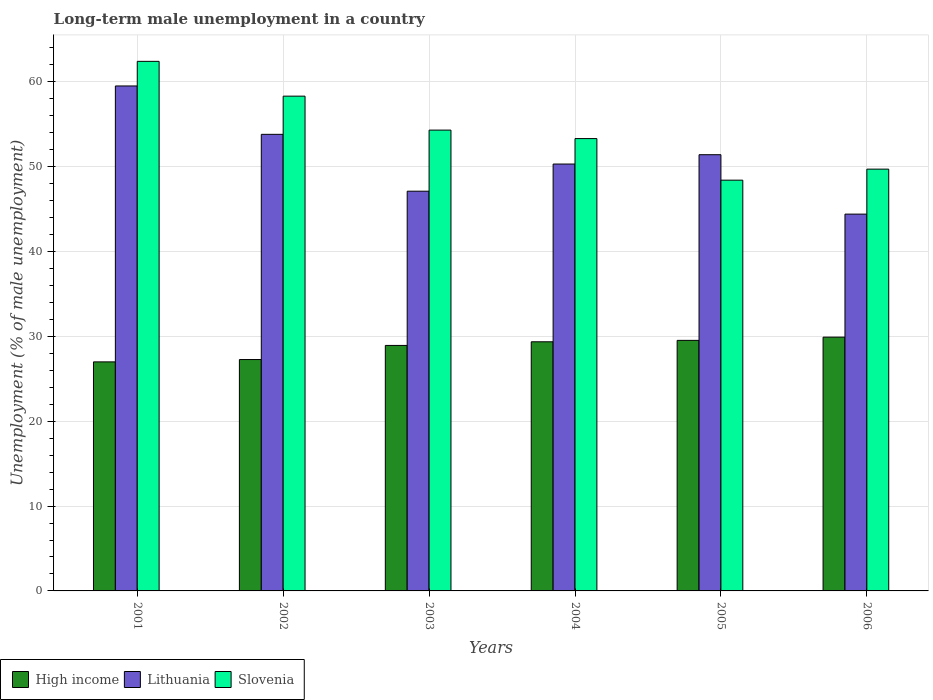How many different coloured bars are there?
Provide a succinct answer. 3. Are the number of bars on each tick of the X-axis equal?
Your answer should be very brief. Yes. How many bars are there on the 2nd tick from the left?
Your answer should be very brief. 3. How many bars are there on the 5th tick from the right?
Provide a succinct answer. 3. In how many cases, is the number of bars for a given year not equal to the number of legend labels?
Keep it short and to the point. 0. What is the percentage of long-term unemployed male population in High income in 2001?
Make the answer very short. 26.99. Across all years, what is the maximum percentage of long-term unemployed male population in Lithuania?
Ensure brevity in your answer.  59.5. Across all years, what is the minimum percentage of long-term unemployed male population in Lithuania?
Your answer should be compact. 44.4. In which year was the percentage of long-term unemployed male population in Lithuania maximum?
Give a very brief answer. 2001. What is the total percentage of long-term unemployed male population in Slovenia in the graph?
Ensure brevity in your answer.  326.4. What is the difference between the percentage of long-term unemployed male population in Slovenia in 2001 and that in 2006?
Give a very brief answer. 12.7. What is the difference between the percentage of long-term unemployed male population in Lithuania in 2003 and the percentage of long-term unemployed male population in Slovenia in 2004?
Offer a very short reply. -6.2. What is the average percentage of long-term unemployed male population in Lithuania per year?
Give a very brief answer. 51.08. In the year 2003, what is the difference between the percentage of long-term unemployed male population in High income and percentage of long-term unemployed male population in Slovenia?
Keep it short and to the point. -25.37. What is the ratio of the percentage of long-term unemployed male population in Lithuania in 2002 to that in 2006?
Your answer should be very brief. 1.21. Is the percentage of long-term unemployed male population in Lithuania in 2005 less than that in 2006?
Give a very brief answer. No. Is the difference between the percentage of long-term unemployed male population in High income in 2002 and 2005 greater than the difference between the percentage of long-term unemployed male population in Slovenia in 2002 and 2005?
Your response must be concise. No. What is the difference between the highest and the second highest percentage of long-term unemployed male population in Slovenia?
Offer a very short reply. 4.1. What is the difference between the highest and the lowest percentage of long-term unemployed male population in High income?
Keep it short and to the point. 2.92. Is the sum of the percentage of long-term unemployed male population in Slovenia in 2002 and 2006 greater than the maximum percentage of long-term unemployed male population in Lithuania across all years?
Ensure brevity in your answer.  Yes. What does the 2nd bar from the left in 2002 represents?
Offer a terse response. Lithuania. What does the 3rd bar from the right in 2003 represents?
Your response must be concise. High income. How many bars are there?
Offer a terse response. 18. What is the difference between two consecutive major ticks on the Y-axis?
Provide a succinct answer. 10. Are the values on the major ticks of Y-axis written in scientific E-notation?
Offer a terse response. No. Does the graph contain any zero values?
Your answer should be very brief. No. How are the legend labels stacked?
Offer a very short reply. Horizontal. What is the title of the graph?
Keep it short and to the point. Long-term male unemployment in a country. Does "Japan" appear as one of the legend labels in the graph?
Provide a short and direct response. No. What is the label or title of the Y-axis?
Provide a succinct answer. Unemployment (% of male unemployment). What is the Unemployment (% of male unemployment) in High income in 2001?
Provide a succinct answer. 26.99. What is the Unemployment (% of male unemployment) in Lithuania in 2001?
Offer a terse response. 59.5. What is the Unemployment (% of male unemployment) of Slovenia in 2001?
Make the answer very short. 62.4. What is the Unemployment (% of male unemployment) of High income in 2002?
Offer a very short reply. 27.26. What is the Unemployment (% of male unemployment) of Lithuania in 2002?
Give a very brief answer. 53.8. What is the Unemployment (% of male unemployment) of Slovenia in 2002?
Your answer should be compact. 58.3. What is the Unemployment (% of male unemployment) in High income in 2003?
Your response must be concise. 28.93. What is the Unemployment (% of male unemployment) in Lithuania in 2003?
Offer a very short reply. 47.1. What is the Unemployment (% of male unemployment) in Slovenia in 2003?
Your response must be concise. 54.3. What is the Unemployment (% of male unemployment) in High income in 2004?
Ensure brevity in your answer.  29.36. What is the Unemployment (% of male unemployment) in Lithuania in 2004?
Make the answer very short. 50.3. What is the Unemployment (% of male unemployment) of Slovenia in 2004?
Provide a short and direct response. 53.3. What is the Unemployment (% of male unemployment) in High income in 2005?
Give a very brief answer. 29.52. What is the Unemployment (% of male unemployment) in Lithuania in 2005?
Give a very brief answer. 51.4. What is the Unemployment (% of male unemployment) of Slovenia in 2005?
Provide a succinct answer. 48.4. What is the Unemployment (% of male unemployment) in High income in 2006?
Keep it short and to the point. 29.91. What is the Unemployment (% of male unemployment) of Lithuania in 2006?
Give a very brief answer. 44.4. What is the Unemployment (% of male unemployment) of Slovenia in 2006?
Your answer should be very brief. 49.7. Across all years, what is the maximum Unemployment (% of male unemployment) in High income?
Make the answer very short. 29.91. Across all years, what is the maximum Unemployment (% of male unemployment) in Lithuania?
Offer a terse response. 59.5. Across all years, what is the maximum Unemployment (% of male unemployment) of Slovenia?
Make the answer very short. 62.4. Across all years, what is the minimum Unemployment (% of male unemployment) of High income?
Offer a very short reply. 26.99. Across all years, what is the minimum Unemployment (% of male unemployment) in Lithuania?
Offer a terse response. 44.4. Across all years, what is the minimum Unemployment (% of male unemployment) of Slovenia?
Offer a terse response. 48.4. What is the total Unemployment (% of male unemployment) of High income in the graph?
Provide a succinct answer. 171.96. What is the total Unemployment (% of male unemployment) of Lithuania in the graph?
Provide a short and direct response. 306.5. What is the total Unemployment (% of male unemployment) of Slovenia in the graph?
Make the answer very short. 326.4. What is the difference between the Unemployment (% of male unemployment) in High income in 2001 and that in 2002?
Offer a terse response. -0.28. What is the difference between the Unemployment (% of male unemployment) of Lithuania in 2001 and that in 2002?
Make the answer very short. 5.7. What is the difference between the Unemployment (% of male unemployment) in Slovenia in 2001 and that in 2002?
Ensure brevity in your answer.  4.1. What is the difference between the Unemployment (% of male unemployment) in High income in 2001 and that in 2003?
Provide a succinct answer. -1.94. What is the difference between the Unemployment (% of male unemployment) in Lithuania in 2001 and that in 2003?
Your response must be concise. 12.4. What is the difference between the Unemployment (% of male unemployment) in Slovenia in 2001 and that in 2003?
Keep it short and to the point. 8.1. What is the difference between the Unemployment (% of male unemployment) of High income in 2001 and that in 2004?
Make the answer very short. -2.37. What is the difference between the Unemployment (% of male unemployment) in Lithuania in 2001 and that in 2004?
Make the answer very short. 9.2. What is the difference between the Unemployment (% of male unemployment) in Slovenia in 2001 and that in 2004?
Make the answer very short. 9.1. What is the difference between the Unemployment (% of male unemployment) of High income in 2001 and that in 2005?
Offer a terse response. -2.53. What is the difference between the Unemployment (% of male unemployment) in Slovenia in 2001 and that in 2005?
Offer a terse response. 14. What is the difference between the Unemployment (% of male unemployment) of High income in 2001 and that in 2006?
Provide a short and direct response. -2.92. What is the difference between the Unemployment (% of male unemployment) in Lithuania in 2001 and that in 2006?
Your response must be concise. 15.1. What is the difference between the Unemployment (% of male unemployment) in Slovenia in 2001 and that in 2006?
Keep it short and to the point. 12.7. What is the difference between the Unemployment (% of male unemployment) in High income in 2002 and that in 2003?
Offer a very short reply. -1.66. What is the difference between the Unemployment (% of male unemployment) in Slovenia in 2002 and that in 2003?
Give a very brief answer. 4. What is the difference between the Unemployment (% of male unemployment) of High income in 2002 and that in 2004?
Your answer should be compact. -2.09. What is the difference between the Unemployment (% of male unemployment) of Lithuania in 2002 and that in 2004?
Give a very brief answer. 3.5. What is the difference between the Unemployment (% of male unemployment) of Slovenia in 2002 and that in 2004?
Ensure brevity in your answer.  5. What is the difference between the Unemployment (% of male unemployment) of High income in 2002 and that in 2005?
Your response must be concise. -2.26. What is the difference between the Unemployment (% of male unemployment) of Slovenia in 2002 and that in 2005?
Provide a succinct answer. 9.9. What is the difference between the Unemployment (% of male unemployment) in High income in 2002 and that in 2006?
Ensure brevity in your answer.  -2.64. What is the difference between the Unemployment (% of male unemployment) of High income in 2003 and that in 2004?
Keep it short and to the point. -0.43. What is the difference between the Unemployment (% of male unemployment) in Slovenia in 2003 and that in 2004?
Your answer should be compact. 1. What is the difference between the Unemployment (% of male unemployment) in High income in 2003 and that in 2005?
Give a very brief answer. -0.6. What is the difference between the Unemployment (% of male unemployment) of Lithuania in 2003 and that in 2005?
Provide a short and direct response. -4.3. What is the difference between the Unemployment (% of male unemployment) of High income in 2003 and that in 2006?
Provide a succinct answer. -0.98. What is the difference between the Unemployment (% of male unemployment) in High income in 2004 and that in 2005?
Offer a very short reply. -0.17. What is the difference between the Unemployment (% of male unemployment) of Lithuania in 2004 and that in 2005?
Your answer should be compact. -1.1. What is the difference between the Unemployment (% of male unemployment) of Slovenia in 2004 and that in 2005?
Ensure brevity in your answer.  4.9. What is the difference between the Unemployment (% of male unemployment) of High income in 2004 and that in 2006?
Ensure brevity in your answer.  -0.55. What is the difference between the Unemployment (% of male unemployment) in High income in 2005 and that in 2006?
Offer a very short reply. -0.38. What is the difference between the Unemployment (% of male unemployment) of Lithuania in 2005 and that in 2006?
Keep it short and to the point. 7. What is the difference between the Unemployment (% of male unemployment) of High income in 2001 and the Unemployment (% of male unemployment) of Lithuania in 2002?
Offer a terse response. -26.81. What is the difference between the Unemployment (% of male unemployment) of High income in 2001 and the Unemployment (% of male unemployment) of Slovenia in 2002?
Give a very brief answer. -31.31. What is the difference between the Unemployment (% of male unemployment) of Lithuania in 2001 and the Unemployment (% of male unemployment) of Slovenia in 2002?
Make the answer very short. 1.2. What is the difference between the Unemployment (% of male unemployment) in High income in 2001 and the Unemployment (% of male unemployment) in Lithuania in 2003?
Provide a short and direct response. -20.11. What is the difference between the Unemployment (% of male unemployment) of High income in 2001 and the Unemployment (% of male unemployment) of Slovenia in 2003?
Give a very brief answer. -27.31. What is the difference between the Unemployment (% of male unemployment) in High income in 2001 and the Unemployment (% of male unemployment) in Lithuania in 2004?
Your response must be concise. -23.31. What is the difference between the Unemployment (% of male unemployment) of High income in 2001 and the Unemployment (% of male unemployment) of Slovenia in 2004?
Your answer should be very brief. -26.31. What is the difference between the Unemployment (% of male unemployment) of High income in 2001 and the Unemployment (% of male unemployment) of Lithuania in 2005?
Make the answer very short. -24.41. What is the difference between the Unemployment (% of male unemployment) of High income in 2001 and the Unemployment (% of male unemployment) of Slovenia in 2005?
Make the answer very short. -21.41. What is the difference between the Unemployment (% of male unemployment) in High income in 2001 and the Unemployment (% of male unemployment) in Lithuania in 2006?
Offer a very short reply. -17.41. What is the difference between the Unemployment (% of male unemployment) of High income in 2001 and the Unemployment (% of male unemployment) of Slovenia in 2006?
Offer a very short reply. -22.71. What is the difference between the Unemployment (% of male unemployment) in High income in 2002 and the Unemployment (% of male unemployment) in Lithuania in 2003?
Offer a very short reply. -19.84. What is the difference between the Unemployment (% of male unemployment) of High income in 2002 and the Unemployment (% of male unemployment) of Slovenia in 2003?
Ensure brevity in your answer.  -27.04. What is the difference between the Unemployment (% of male unemployment) in Lithuania in 2002 and the Unemployment (% of male unemployment) in Slovenia in 2003?
Make the answer very short. -0.5. What is the difference between the Unemployment (% of male unemployment) in High income in 2002 and the Unemployment (% of male unemployment) in Lithuania in 2004?
Offer a terse response. -23.04. What is the difference between the Unemployment (% of male unemployment) in High income in 2002 and the Unemployment (% of male unemployment) in Slovenia in 2004?
Make the answer very short. -26.04. What is the difference between the Unemployment (% of male unemployment) of Lithuania in 2002 and the Unemployment (% of male unemployment) of Slovenia in 2004?
Your answer should be compact. 0.5. What is the difference between the Unemployment (% of male unemployment) in High income in 2002 and the Unemployment (% of male unemployment) in Lithuania in 2005?
Your answer should be compact. -24.14. What is the difference between the Unemployment (% of male unemployment) of High income in 2002 and the Unemployment (% of male unemployment) of Slovenia in 2005?
Your answer should be compact. -21.14. What is the difference between the Unemployment (% of male unemployment) in High income in 2002 and the Unemployment (% of male unemployment) in Lithuania in 2006?
Your answer should be compact. -17.14. What is the difference between the Unemployment (% of male unemployment) of High income in 2002 and the Unemployment (% of male unemployment) of Slovenia in 2006?
Offer a terse response. -22.44. What is the difference between the Unemployment (% of male unemployment) of Lithuania in 2002 and the Unemployment (% of male unemployment) of Slovenia in 2006?
Your response must be concise. 4.1. What is the difference between the Unemployment (% of male unemployment) in High income in 2003 and the Unemployment (% of male unemployment) in Lithuania in 2004?
Offer a terse response. -21.37. What is the difference between the Unemployment (% of male unemployment) of High income in 2003 and the Unemployment (% of male unemployment) of Slovenia in 2004?
Ensure brevity in your answer.  -24.37. What is the difference between the Unemployment (% of male unemployment) in Lithuania in 2003 and the Unemployment (% of male unemployment) in Slovenia in 2004?
Offer a very short reply. -6.2. What is the difference between the Unemployment (% of male unemployment) of High income in 2003 and the Unemployment (% of male unemployment) of Lithuania in 2005?
Your response must be concise. -22.47. What is the difference between the Unemployment (% of male unemployment) of High income in 2003 and the Unemployment (% of male unemployment) of Slovenia in 2005?
Give a very brief answer. -19.47. What is the difference between the Unemployment (% of male unemployment) in Lithuania in 2003 and the Unemployment (% of male unemployment) in Slovenia in 2005?
Offer a very short reply. -1.3. What is the difference between the Unemployment (% of male unemployment) in High income in 2003 and the Unemployment (% of male unemployment) in Lithuania in 2006?
Offer a terse response. -15.47. What is the difference between the Unemployment (% of male unemployment) in High income in 2003 and the Unemployment (% of male unemployment) in Slovenia in 2006?
Offer a very short reply. -20.77. What is the difference between the Unemployment (% of male unemployment) of Lithuania in 2003 and the Unemployment (% of male unemployment) of Slovenia in 2006?
Offer a terse response. -2.6. What is the difference between the Unemployment (% of male unemployment) of High income in 2004 and the Unemployment (% of male unemployment) of Lithuania in 2005?
Offer a terse response. -22.04. What is the difference between the Unemployment (% of male unemployment) of High income in 2004 and the Unemployment (% of male unemployment) of Slovenia in 2005?
Your answer should be very brief. -19.04. What is the difference between the Unemployment (% of male unemployment) in High income in 2004 and the Unemployment (% of male unemployment) in Lithuania in 2006?
Offer a terse response. -15.04. What is the difference between the Unemployment (% of male unemployment) of High income in 2004 and the Unemployment (% of male unemployment) of Slovenia in 2006?
Your answer should be compact. -20.34. What is the difference between the Unemployment (% of male unemployment) in Lithuania in 2004 and the Unemployment (% of male unemployment) in Slovenia in 2006?
Keep it short and to the point. 0.6. What is the difference between the Unemployment (% of male unemployment) of High income in 2005 and the Unemployment (% of male unemployment) of Lithuania in 2006?
Your response must be concise. -14.88. What is the difference between the Unemployment (% of male unemployment) in High income in 2005 and the Unemployment (% of male unemployment) in Slovenia in 2006?
Ensure brevity in your answer.  -20.18. What is the difference between the Unemployment (% of male unemployment) in Lithuania in 2005 and the Unemployment (% of male unemployment) in Slovenia in 2006?
Ensure brevity in your answer.  1.7. What is the average Unemployment (% of male unemployment) in High income per year?
Provide a short and direct response. 28.66. What is the average Unemployment (% of male unemployment) in Lithuania per year?
Provide a short and direct response. 51.08. What is the average Unemployment (% of male unemployment) in Slovenia per year?
Offer a terse response. 54.4. In the year 2001, what is the difference between the Unemployment (% of male unemployment) in High income and Unemployment (% of male unemployment) in Lithuania?
Provide a succinct answer. -32.51. In the year 2001, what is the difference between the Unemployment (% of male unemployment) of High income and Unemployment (% of male unemployment) of Slovenia?
Your response must be concise. -35.41. In the year 2002, what is the difference between the Unemployment (% of male unemployment) in High income and Unemployment (% of male unemployment) in Lithuania?
Your response must be concise. -26.54. In the year 2002, what is the difference between the Unemployment (% of male unemployment) of High income and Unemployment (% of male unemployment) of Slovenia?
Offer a very short reply. -31.04. In the year 2003, what is the difference between the Unemployment (% of male unemployment) of High income and Unemployment (% of male unemployment) of Lithuania?
Keep it short and to the point. -18.17. In the year 2003, what is the difference between the Unemployment (% of male unemployment) in High income and Unemployment (% of male unemployment) in Slovenia?
Make the answer very short. -25.37. In the year 2003, what is the difference between the Unemployment (% of male unemployment) in Lithuania and Unemployment (% of male unemployment) in Slovenia?
Offer a very short reply. -7.2. In the year 2004, what is the difference between the Unemployment (% of male unemployment) in High income and Unemployment (% of male unemployment) in Lithuania?
Your response must be concise. -20.94. In the year 2004, what is the difference between the Unemployment (% of male unemployment) of High income and Unemployment (% of male unemployment) of Slovenia?
Offer a very short reply. -23.94. In the year 2005, what is the difference between the Unemployment (% of male unemployment) of High income and Unemployment (% of male unemployment) of Lithuania?
Your response must be concise. -21.88. In the year 2005, what is the difference between the Unemployment (% of male unemployment) in High income and Unemployment (% of male unemployment) in Slovenia?
Your response must be concise. -18.88. In the year 2005, what is the difference between the Unemployment (% of male unemployment) in Lithuania and Unemployment (% of male unemployment) in Slovenia?
Provide a short and direct response. 3. In the year 2006, what is the difference between the Unemployment (% of male unemployment) of High income and Unemployment (% of male unemployment) of Lithuania?
Keep it short and to the point. -14.49. In the year 2006, what is the difference between the Unemployment (% of male unemployment) in High income and Unemployment (% of male unemployment) in Slovenia?
Your answer should be very brief. -19.79. What is the ratio of the Unemployment (% of male unemployment) of Lithuania in 2001 to that in 2002?
Make the answer very short. 1.11. What is the ratio of the Unemployment (% of male unemployment) in Slovenia in 2001 to that in 2002?
Provide a short and direct response. 1.07. What is the ratio of the Unemployment (% of male unemployment) of High income in 2001 to that in 2003?
Provide a short and direct response. 0.93. What is the ratio of the Unemployment (% of male unemployment) in Lithuania in 2001 to that in 2003?
Offer a terse response. 1.26. What is the ratio of the Unemployment (% of male unemployment) in Slovenia in 2001 to that in 2003?
Make the answer very short. 1.15. What is the ratio of the Unemployment (% of male unemployment) of High income in 2001 to that in 2004?
Ensure brevity in your answer.  0.92. What is the ratio of the Unemployment (% of male unemployment) of Lithuania in 2001 to that in 2004?
Offer a terse response. 1.18. What is the ratio of the Unemployment (% of male unemployment) in Slovenia in 2001 to that in 2004?
Keep it short and to the point. 1.17. What is the ratio of the Unemployment (% of male unemployment) of High income in 2001 to that in 2005?
Provide a short and direct response. 0.91. What is the ratio of the Unemployment (% of male unemployment) of Lithuania in 2001 to that in 2005?
Your answer should be compact. 1.16. What is the ratio of the Unemployment (% of male unemployment) in Slovenia in 2001 to that in 2005?
Your answer should be very brief. 1.29. What is the ratio of the Unemployment (% of male unemployment) of High income in 2001 to that in 2006?
Keep it short and to the point. 0.9. What is the ratio of the Unemployment (% of male unemployment) in Lithuania in 2001 to that in 2006?
Make the answer very short. 1.34. What is the ratio of the Unemployment (% of male unemployment) of Slovenia in 2001 to that in 2006?
Your answer should be very brief. 1.26. What is the ratio of the Unemployment (% of male unemployment) of High income in 2002 to that in 2003?
Your answer should be very brief. 0.94. What is the ratio of the Unemployment (% of male unemployment) in Lithuania in 2002 to that in 2003?
Offer a very short reply. 1.14. What is the ratio of the Unemployment (% of male unemployment) of Slovenia in 2002 to that in 2003?
Provide a succinct answer. 1.07. What is the ratio of the Unemployment (% of male unemployment) in High income in 2002 to that in 2004?
Offer a terse response. 0.93. What is the ratio of the Unemployment (% of male unemployment) in Lithuania in 2002 to that in 2004?
Your answer should be compact. 1.07. What is the ratio of the Unemployment (% of male unemployment) in Slovenia in 2002 to that in 2004?
Keep it short and to the point. 1.09. What is the ratio of the Unemployment (% of male unemployment) of High income in 2002 to that in 2005?
Offer a terse response. 0.92. What is the ratio of the Unemployment (% of male unemployment) in Lithuania in 2002 to that in 2005?
Your answer should be compact. 1.05. What is the ratio of the Unemployment (% of male unemployment) of Slovenia in 2002 to that in 2005?
Ensure brevity in your answer.  1.2. What is the ratio of the Unemployment (% of male unemployment) in High income in 2002 to that in 2006?
Offer a terse response. 0.91. What is the ratio of the Unemployment (% of male unemployment) in Lithuania in 2002 to that in 2006?
Provide a succinct answer. 1.21. What is the ratio of the Unemployment (% of male unemployment) in Slovenia in 2002 to that in 2006?
Your answer should be very brief. 1.17. What is the ratio of the Unemployment (% of male unemployment) in High income in 2003 to that in 2004?
Make the answer very short. 0.99. What is the ratio of the Unemployment (% of male unemployment) of Lithuania in 2003 to that in 2004?
Give a very brief answer. 0.94. What is the ratio of the Unemployment (% of male unemployment) of Slovenia in 2003 to that in 2004?
Provide a succinct answer. 1.02. What is the ratio of the Unemployment (% of male unemployment) in High income in 2003 to that in 2005?
Provide a short and direct response. 0.98. What is the ratio of the Unemployment (% of male unemployment) in Lithuania in 2003 to that in 2005?
Keep it short and to the point. 0.92. What is the ratio of the Unemployment (% of male unemployment) of Slovenia in 2003 to that in 2005?
Offer a terse response. 1.12. What is the ratio of the Unemployment (% of male unemployment) of High income in 2003 to that in 2006?
Provide a succinct answer. 0.97. What is the ratio of the Unemployment (% of male unemployment) in Lithuania in 2003 to that in 2006?
Provide a short and direct response. 1.06. What is the ratio of the Unemployment (% of male unemployment) in Slovenia in 2003 to that in 2006?
Offer a very short reply. 1.09. What is the ratio of the Unemployment (% of male unemployment) of High income in 2004 to that in 2005?
Provide a succinct answer. 0.99. What is the ratio of the Unemployment (% of male unemployment) in Lithuania in 2004 to that in 2005?
Give a very brief answer. 0.98. What is the ratio of the Unemployment (% of male unemployment) in Slovenia in 2004 to that in 2005?
Offer a terse response. 1.1. What is the ratio of the Unemployment (% of male unemployment) in High income in 2004 to that in 2006?
Give a very brief answer. 0.98. What is the ratio of the Unemployment (% of male unemployment) in Lithuania in 2004 to that in 2006?
Provide a short and direct response. 1.13. What is the ratio of the Unemployment (% of male unemployment) in Slovenia in 2004 to that in 2006?
Offer a very short reply. 1.07. What is the ratio of the Unemployment (% of male unemployment) in High income in 2005 to that in 2006?
Offer a terse response. 0.99. What is the ratio of the Unemployment (% of male unemployment) in Lithuania in 2005 to that in 2006?
Offer a terse response. 1.16. What is the ratio of the Unemployment (% of male unemployment) in Slovenia in 2005 to that in 2006?
Provide a succinct answer. 0.97. What is the difference between the highest and the second highest Unemployment (% of male unemployment) in High income?
Your answer should be very brief. 0.38. What is the difference between the highest and the second highest Unemployment (% of male unemployment) of Lithuania?
Ensure brevity in your answer.  5.7. What is the difference between the highest and the second highest Unemployment (% of male unemployment) in Slovenia?
Offer a very short reply. 4.1. What is the difference between the highest and the lowest Unemployment (% of male unemployment) in High income?
Make the answer very short. 2.92. What is the difference between the highest and the lowest Unemployment (% of male unemployment) in Slovenia?
Ensure brevity in your answer.  14. 